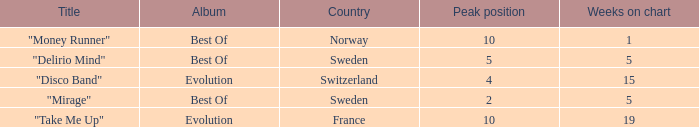What is the most weeks on chart when the peak position is less than 5 and from sweden? 5.0. 